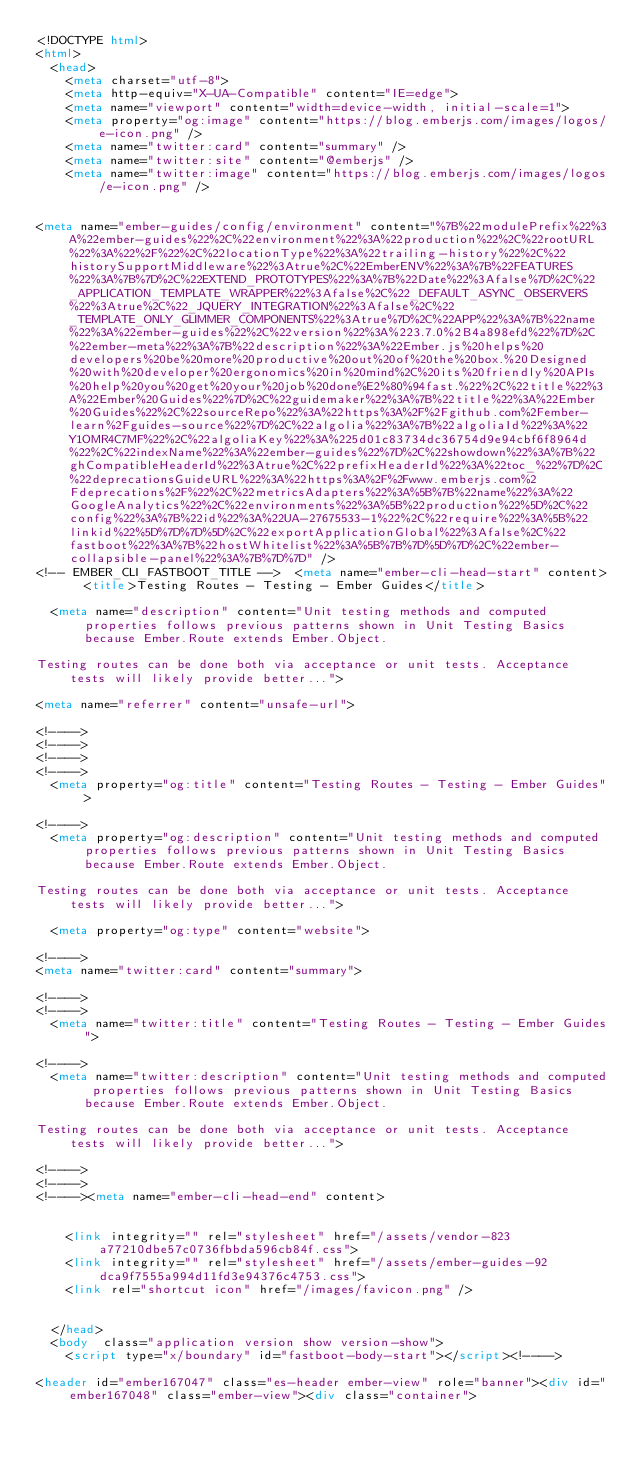Convert code to text. <code><loc_0><loc_0><loc_500><loc_500><_HTML_><!DOCTYPE html>
<html>
  <head>
    <meta charset="utf-8">
    <meta http-equiv="X-UA-Compatible" content="IE=edge">
    <meta name="viewport" content="width=device-width, initial-scale=1">
    <meta property="og:image" content="https://blog.emberjs.com/images/logos/e-icon.png" />
    <meta name="twitter:card" content="summary" />
    <meta name="twitter:site" content="@emberjs" />
    <meta name="twitter:image" content="https://blog.emberjs.com/images/logos/e-icon.png" />

    
<meta name="ember-guides/config/environment" content="%7B%22modulePrefix%22%3A%22ember-guides%22%2C%22environment%22%3A%22production%22%2C%22rootURL%22%3A%22%2F%22%2C%22locationType%22%3A%22trailing-history%22%2C%22historySupportMiddleware%22%3Atrue%2C%22EmberENV%22%3A%7B%22FEATURES%22%3A%7B%7D%2C%22EXTEND_PROTOTYPES%22%3A%7B%22Date%22%3Afalse%7D%2C%22_APPLICATION_TEMPLATE_WRAPPER%22%3Afalse%2C%22_DEFAULT_ASYNC_OBSERVERS%22%3Atrue%2C%22_JQUERY_INTEGRATION%22%3Afalse%2C%22_TEMPLATE_ONLY_GLIMMER_COMPONENTS%22%3Atrue%7D%2C%22APP%22%3A%7B%22name%22%3A%22ember-guides%22%2C%22version%22%3A%223.7.0%2B4a898efd%22%7D%2C%22ember-meta%22%3A%7B%22description%22%3A%22Ember.js%20helps%20developers%20be%20more%20productive%20out%20of%20the%20box.%20Designed%20with%20developer%20ergonomics%20in%20mind%2C%20its%20friendly%20APIs%20help%20you%20get%20your%20job%20done%E2%80%94fast.%22%2C%22title%22%3A%22Ember%20Guides%22%7D%2C%22guidemaker%22%3A%7B%22title%22%3A%22Ember%20Guides%22%2C%22sourceRepo%22%3A%22https%3A%2F%2Fgithub.com%2Fember-learn%2Fguides-source%22%7D%2C%22algolia%22%3A%7B%22algoliaId%22%3A%22Y1OMR4C7MF%22%2C%22algoliaKey%22%3A%225d01c83734dc36754d9e94cbf6f8964d%22%2C%22indexName%22%3A%22ember-guides%22%7D%2C%22showdown%22%3A%7B%22ghCompatibleHeaderId%22%3Atrue%2C%22prefixHeaderId%22%3A%22toc_%22%7D%2C%22deprecationsGuideURL%22%3A%22https%3A%2F%2Fwww.emberjs.com%2Fdeprecations%2F%22%2C%22metricsAdapters%22%3A%5B%7B%22name%22%3A%22GoogleAnalytics%22%2C%22environments%22%3A%5B%22production%22%5D%2C%22config%22%3A%7B%22id%22%3A%22UA-27675533-1%22%2C%22require%22%3A%5B%22linkid%22%5D%7D%7D%5D%2C%22exportApplicationGlobal%22%3Afalse%2C%22fastboot%22%3A%7B%22hostWhitelist%22%3A%5B%7B%7D%5D%7D%2C%22ember-collapsible-panel%22%3A%7B%7D%7D" />
<!-- EMBER_CLI_FASTBOOT_TITLE -->  <meta name="ember-cli-head-start" content>  <title>Testing Routes - Testing - Ember Guides</title>

  <meta name="description" content="Unit testing methods and computed properties follows previous patterns shown in Unit Testing Basics because Ember.Route extends Ember.Object. 

Testing routes can be done both via acceptance or unit tests. Acceptance tests will likely provide better...">

<meta name="referrer" content="unsafe-url">

<!---->
<!---->
<!---->
<!---->
  <meta property="og:title" content="Testing Routes - Testing - Ember Guides">

<!---->
  <meta property="og:description" content="Unit testing methods and computed properties follows previous patterns shown in Unit Testing Basics because Ember.Route extends Ember.Object. 

Testing routes can be done both via acceptance or unit tests. Acceptance tests will likely provide better...">

  <meta property="og:type" content="website">

<!---->
<meta name="twitter:card" content="summary">

<!---->
<!---->
  <meta name="twitter:title" content="Testing Routes - Testing - Ember Guides">

<!---->
  <meta name="twitter:description" content="Unit testing methods and computed properties follows previous patterns shown in Unit Testing Basics because Ember.Route extends Ember.Object. 

Testing routes can be done both via acceptance or unit tests. Acceptance tests will likely provide better...">

<!---->
<!---->
<!----><meta name="ember-cli-head-end" content>


    <link integrity="" rel="stylesheet" href="/assets/vendor-823a77210dbe57c0736fbbda596cb84f.css">
    <link integrity="" rel="stylesheet" href="/assets/ember-guides-92dca9f7555a994d11fd3e94376c4753.css">
    <link rel="shortcut icon" href="/images/favicon.png" />

    
  </head>
  <body  class="application version show version-show">
    <script type="x/boundary" id="fastboot-body-start"></script><!---->

<header id="ember167047" class="es-header ember-view" role="banner"><div id="ember167048" class="ember-view"><div class="container"></code> 